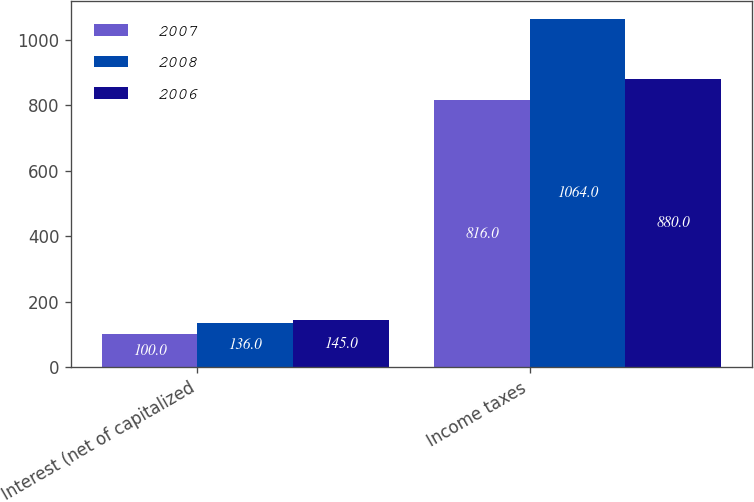Convert chart to OTSL. <chart><loc_0><loc_0><loc_500><loc_500><stacked_bar_chart><ecel><fcel>Interest (net of capitalized<fcel>Income taxes<nl><fcel>2007<fcel>100<fcel>816<nl><fcel>2008<fcel>136<fcel>1064<nl><fcel>2006<fcel>145<fcel>880<nl></chart> 